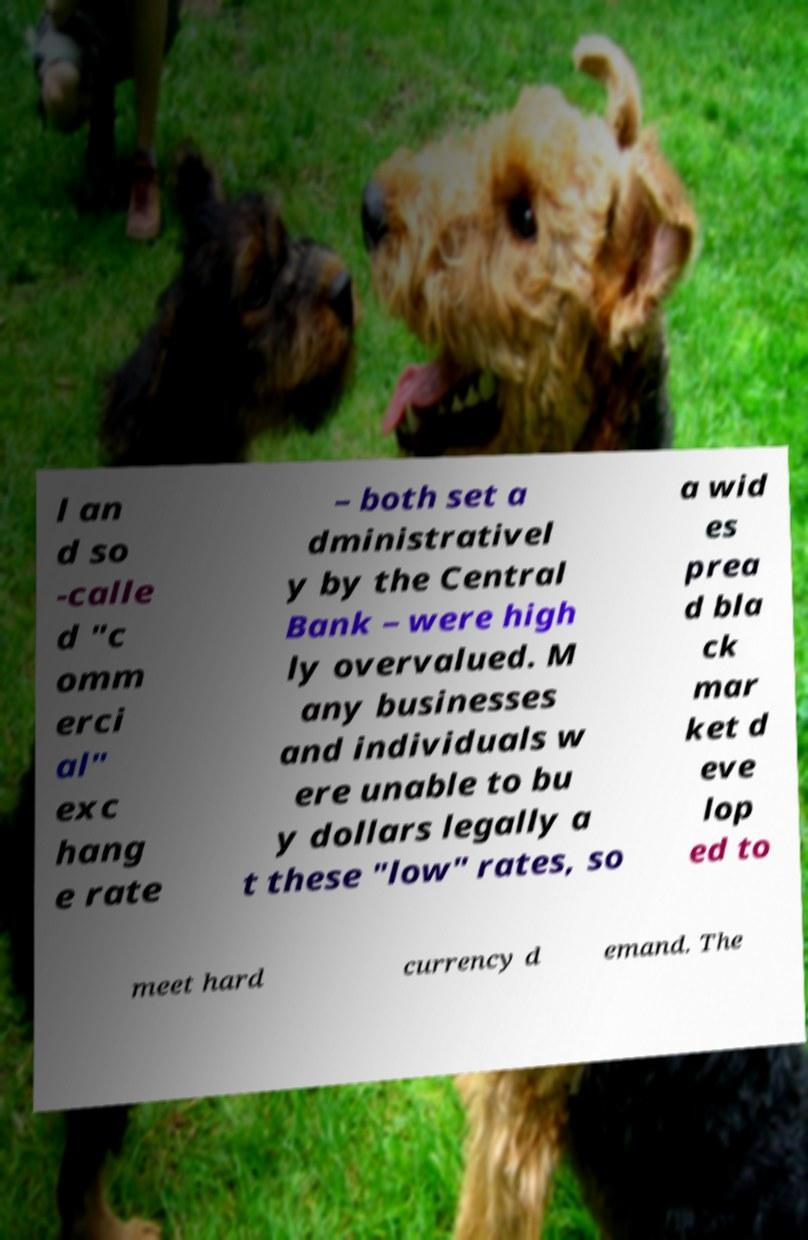Please read and relay the text visible in this image. What does it say? l an d so -calle d "c omm erci al" exc hang e rate – both set a dministrativel y by the Central Bank – were high ly overvalued. M any businesses and individuals w ere unable to bu y dollars legally a t these "low" rates, so a wid es prea d bla ck mar ket d eve lop ed to meet hard currency d emand. The 